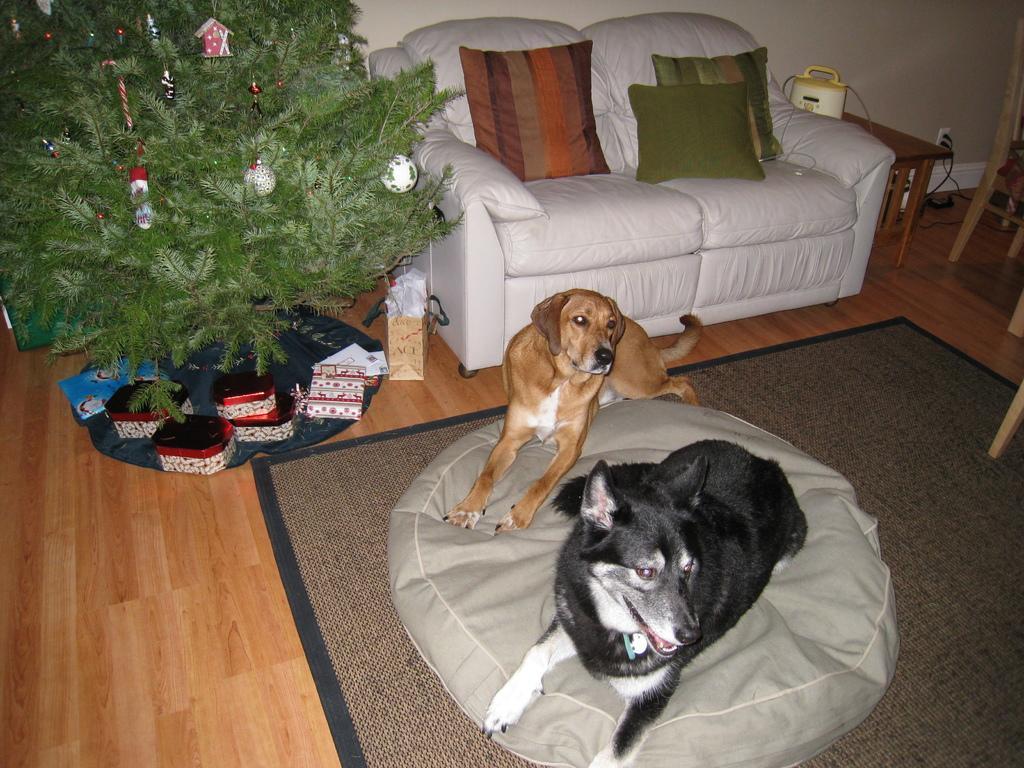Describe this image in one or two sentences. Here we can see a couple of dogs are sitting on a bean bag and behind them there is a couch with cushions on it and beside the couch we can see plant 